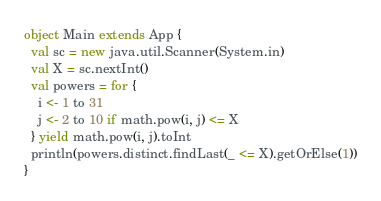Convert code to text. <code><loc_0><loc_0><loc_500><loc_500><_Scala_>object Main extends App {
  val sc = new java.util.Scanner(System.in)
  val X = sc.nextInt()
  val powers = for {
    i <- 1 to 31
    j <- 2 to 10 if math.pow(i, j) <= X
  } yield math.pow(i, j).toInt
  println(powers.distinct.findLast(_ <= X).getOrElse(1))
}
</code> 